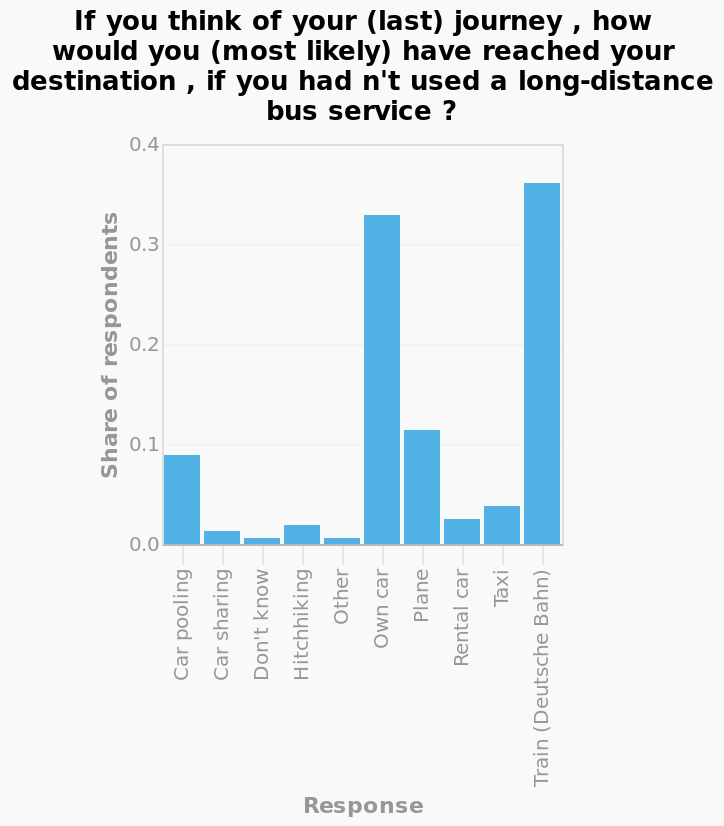<image>
What type of data is represented by the x-axis of the bar graph? The x-axis of the bar graph represents categorical data, specifically different modes of transportation. What is the most popular choice for completing a long distance journey when a long distance bus is not an option?  Trains Are trains and own cars more popular than any of the other options for long distance travel? Yes, they are much more popular 